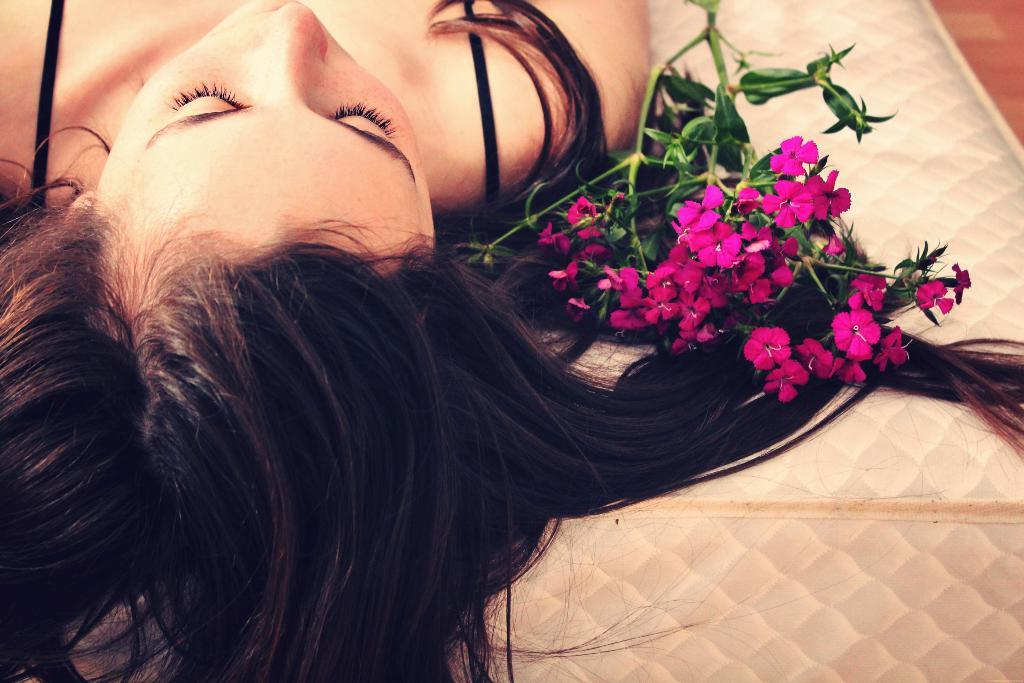Who is present in the image? There is a woman in the image. What is the woman doing in the image? The woman is laying on a bed. What can be seen beside the woman in the image? There is a stem with flowers and leaves beside the woman. What time of day is it in the image? The provided facts do not mention the time of day, so it cannot be determined from the image. Is there a garden visible in the image? No, there is no garden present in the image; only a woman laying on a bed and a stem with flowers and leaves are visible. 